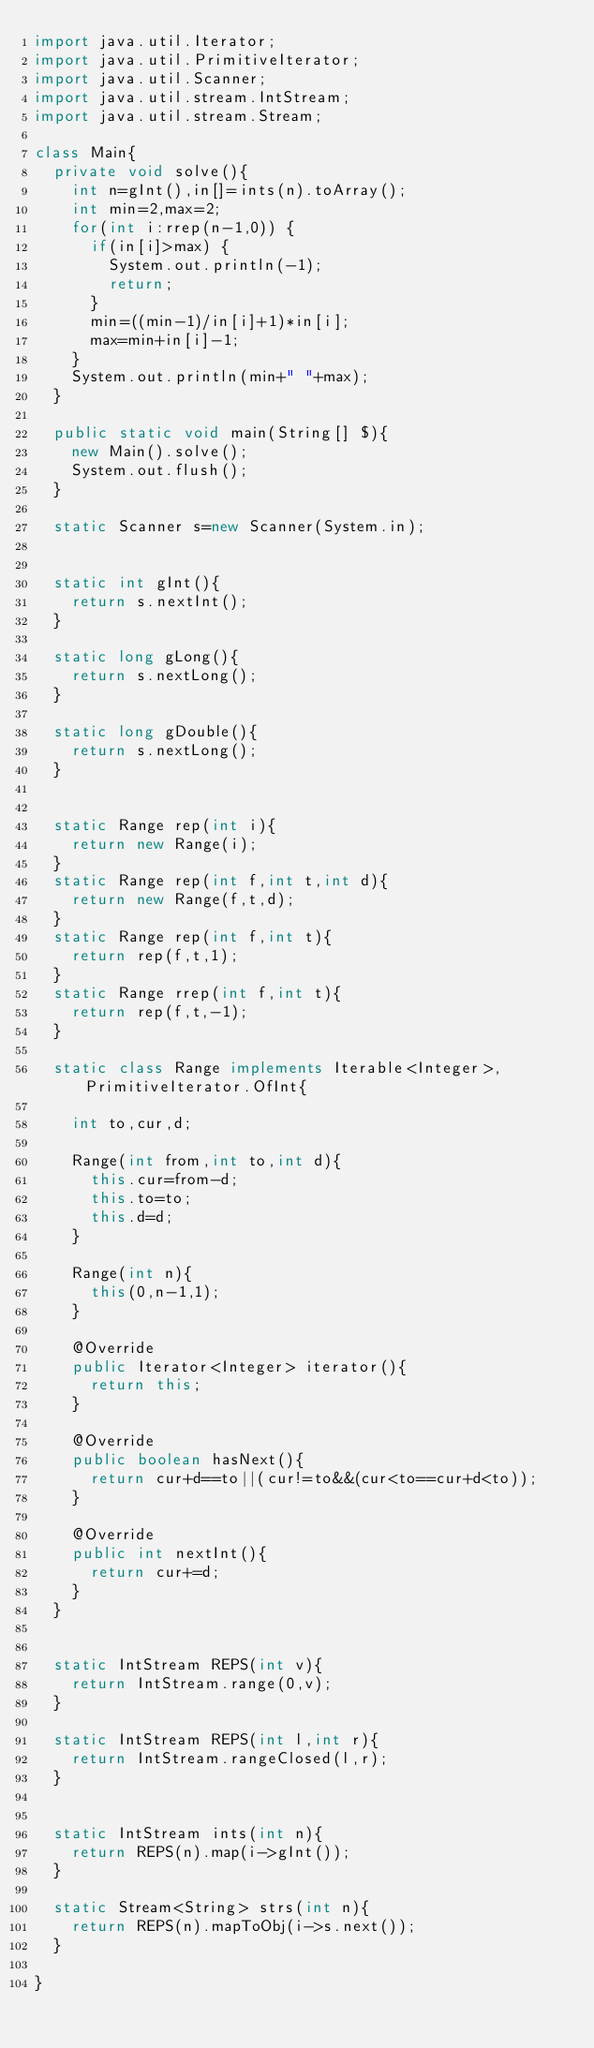Convert code to text. <code><loc_0><loc_0><loc_500><loc_500><_Java_>import java.util.Iterator;
import java.util.PrimitiveIterator;
import java.util.Scanner;
import java.util.stream.IntStream;
import java.util.stream.Stream;

class Main{
	private void solve(){
		int n=gInt(),in[]=ints(n).toArray();
		int min=2,max=2;
		for(int i:rrep(n-1,0)) {
			if(in[i]>max) {
				System.out.println(-1);
				return;
			}
			min=((min-1)/in[i]+1)*in[i];
			max=min+in[i]-1;
		}
		System.out.println(min+" "+max);
	}

	public static void main(String[] $){
		new Main().solve();
		System.out.flush();
	}

	static Scanner s=new Scanner(System.in);


	static int gInt(){
		return s.nextInt();
	}

	static long gLong(){
		return s.nextLong();
	}

	static long gDouble(){
		return s.nextLong();
	}


	static Range rep(int i){
		return new Range(i);
	}
	static Range rep(int f,int t,int d){
		return new Range(f,t,d);
	}
	static Range rep(int f,int t){
		return rep(f,t,1);
	}
	static Range rrep(int f,int t){
		return rep(f,t,-1);
	}

	static class Range implements Iterable<Integer>,PrimitiveIterator.OfInt{

		int to,cur,d;

		Range(int from,int to,int d){
			this.cur=from-d;
			this.to=to;
			this.d=d;
		}

		Range(int n){
			this(0,n-1,1);
		}

		@Override
		public Iterator<Integer> iterator(){
			return this;
		}

		@Override
		public boolean hasNext(){
			return cur+d==to||(cur!=to&&(cur<to==cur+d<to));
		}

		@Override
		public int nextInt(){
			return cur+=d;
		}
	}


	static IntStream REPS(int v){
		return IntStream.range(0,v);
	}

	static IntStream REPS(int l,int r){
		return IntStream.rangeClosed(l,r);
	}


	static IntStream ints(int n){
		return REPS(n).map(i->gInt());
	}

	static Stream<String> strs(int n){
		return REPS(n).mapToObj(i->s.next());
	}

}</code> 